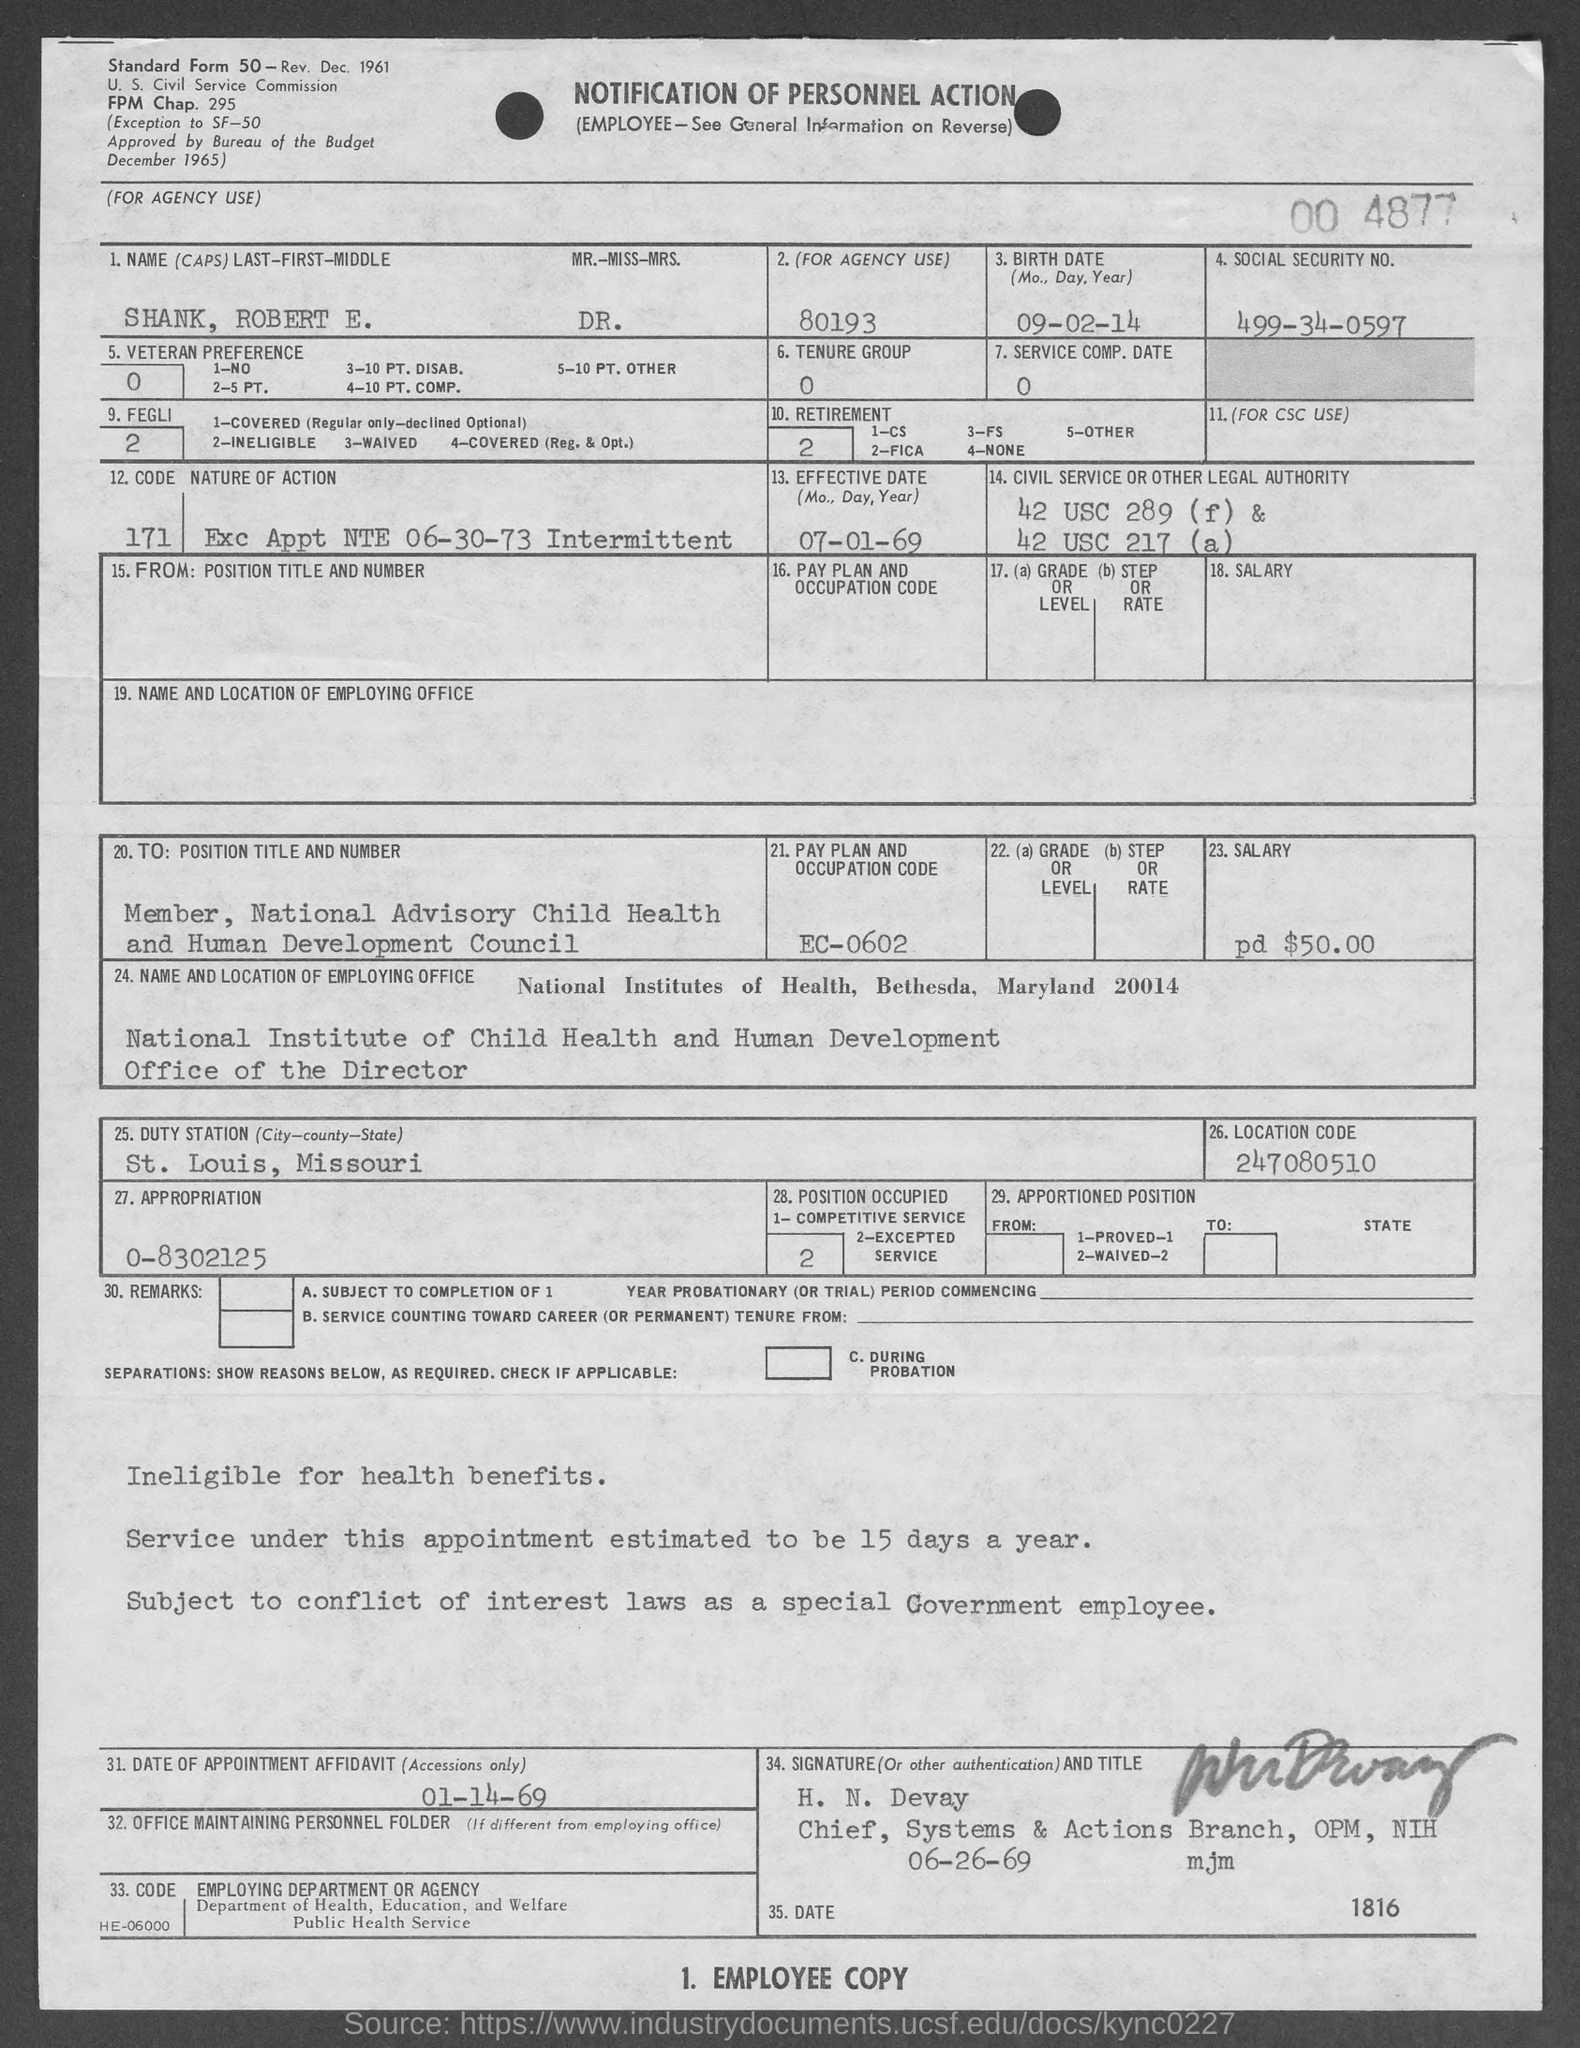What is the pay plan and occupation code mentioned in the form? The pay plan and occupation code mentioned in the form are 'EC-0602'. This code is assigned to positions within certain government agencies, specifying employment characteristics and payment schedules. It might correspond to a specific role or level in the National Advisory Child Health and Human Development Council. 